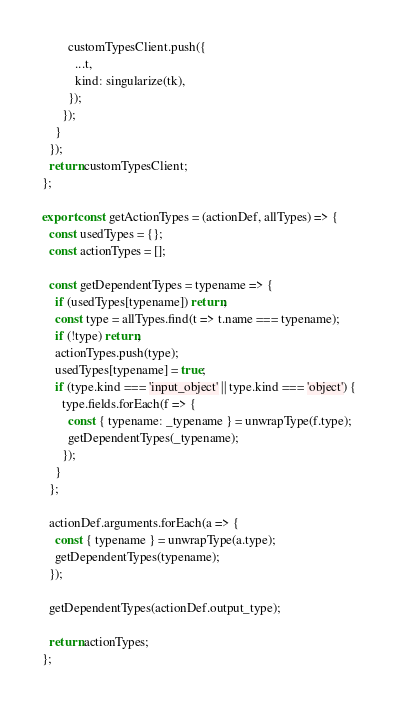<code> <loc_0><loc_0><loc_500><loc_500><_JavaScript_>        customTypesClient.push({
          ...t,
          kind: singularize(tk),
        });
      });
    }
  });
  return customTypesClient;
};

export const getActionTypes = (actionDef, allTypes) => {
  const usedTypes = {};
  const actionTypes = [];

  const getDependentTypes = typename => {
    if (usedTypes[typename]) return;
    const type = allTypes.find(t => t.name === typename);
    if (!type) return;
    actionTypes.push(type);
    usedTypes[typename] = true;
    if (type.kind === 'input_object' || type.kind === 'object') {
      type.fields.forEach(f => {
        const { typename: _typename } = unwrapType(f.type);
        getDependentTypes(_typename);
      });
    }
  };

  actionDef.arguments.forEach(a => {
    const { typename } = unwrapType(a.type);
    getDependentTypes(typename);
  });

  getDependentTypes(actionDef.output_type);

  return actionTypes;
};
</code> 